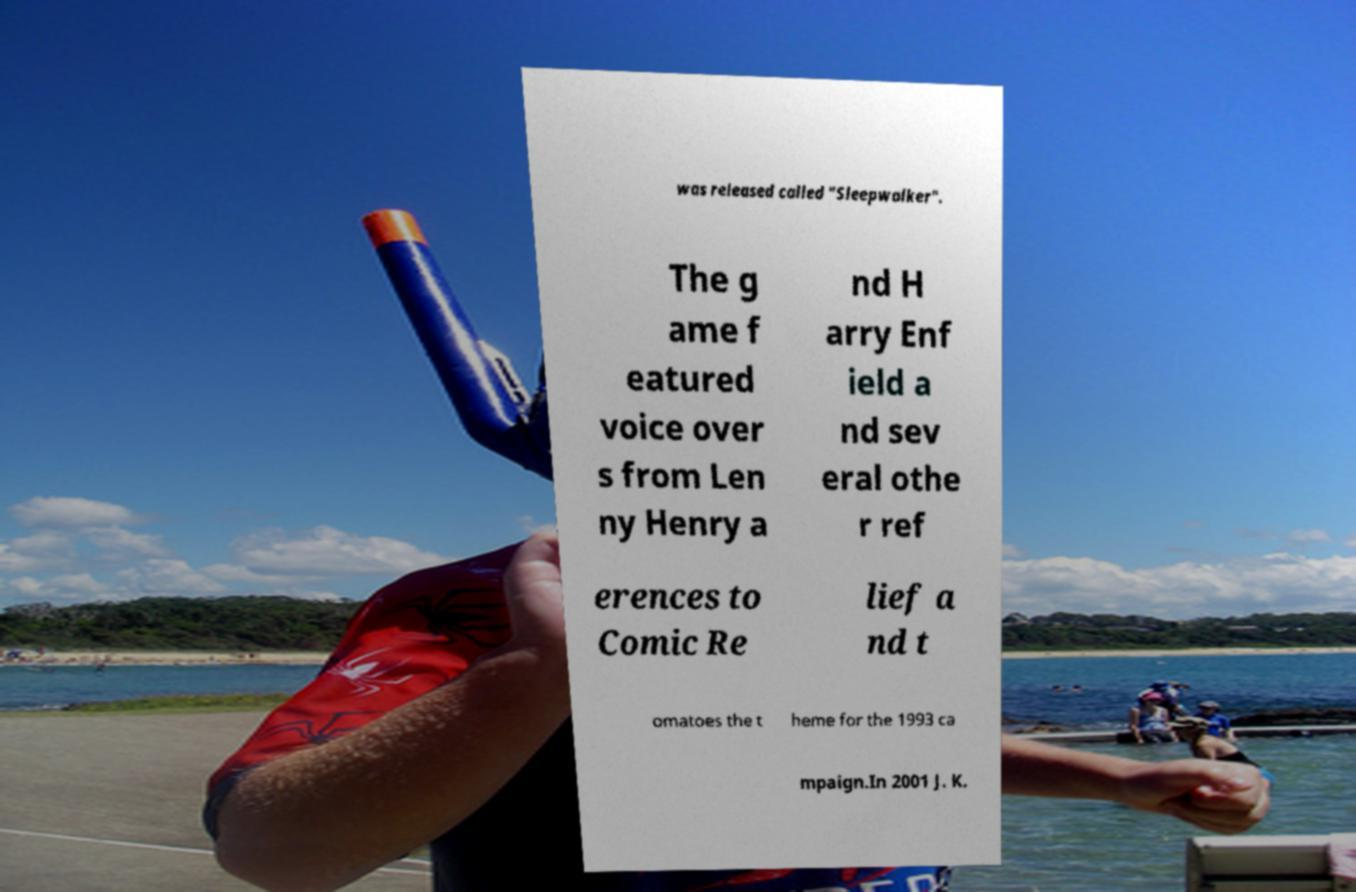Could you extract and type out the text from this image? was released called "Sleepwalker". The g ame f eatured voice over s from Len ny Henry a nd H arry Enf ield a nd sev eral othe r ref erences to Comic Re lief a nd t omatoes the t heme for the 1993 ca mpaign.In 2001 J. K. 